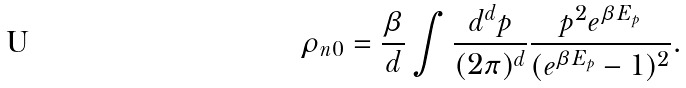<formula> <loc_0><loc_0><loc_500><loc_500>\rho _ { n 0 } = \frac { \beta } { d } \int \frac { d ^ { d } p } { ( 2 \pi ) ^ { d } } \frac { p ^ { 2 } e ^ { \beta E _ { p } } } { ( e ^ { \beta E _ { p } } - 1 ) ^ { 2 } } .</formula> 